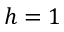Convert formula to latex. <formula><loc_0><loc_0><loc_500><loc_500>h = 1</formula> 